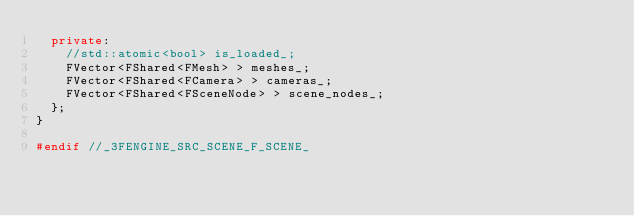<code> <loc_0><loc_0><loc_500><loc_500><_C++_>	private:
		//std::atomic<bool> is_loaded_;
		FVector<FShared<FMesh> > meshes_;
		FVector<FShared<FCamera> > cameras_;
		FVector<FShared<FSceneNode> > scene_nodes_;
	};
}

#endif //_3FENGINE_SRC_SCENE_F_SCENE_</code> 